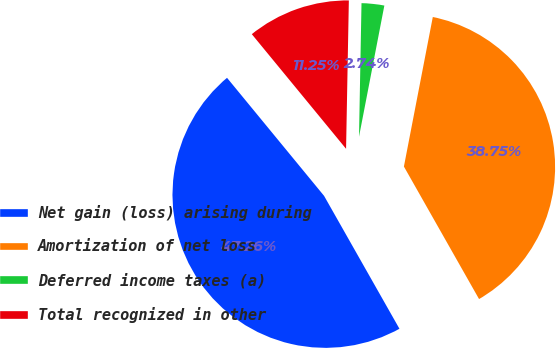<chart> <loc_0><loc_0><loc_500><loc_500><pie_chart><fcel>Net gain (loss) arising during<fcel>Amortization of net loss<fcel>Deferred income taxes (a)<fcel>Total recognized in other<nl><fcel>47.26%<fcel>38.75%<fcel>2.74%<fcel>11.25%<nl></chart> 